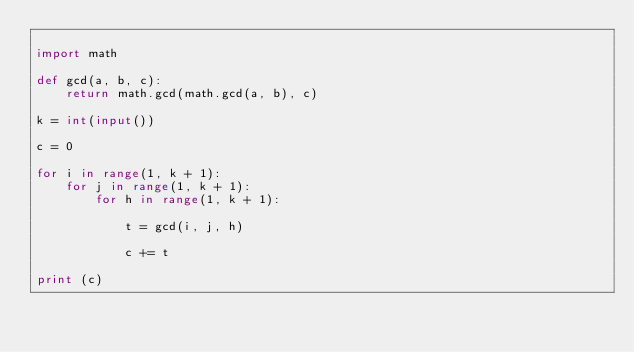<code> <loc_0><loc_0><loc_500><loc_500><_Python_>
import math

def gcd(a, b, c):
    return math.gcd(math.gcd(a, b), c)

k = int(input())

c = 0

for i in range(1, k + 1):
    for j in range(1, k + 1):
        for h in range(1, k + 1):

            t = gcd(i, j, h)

            c += t

print (c)
</code> 